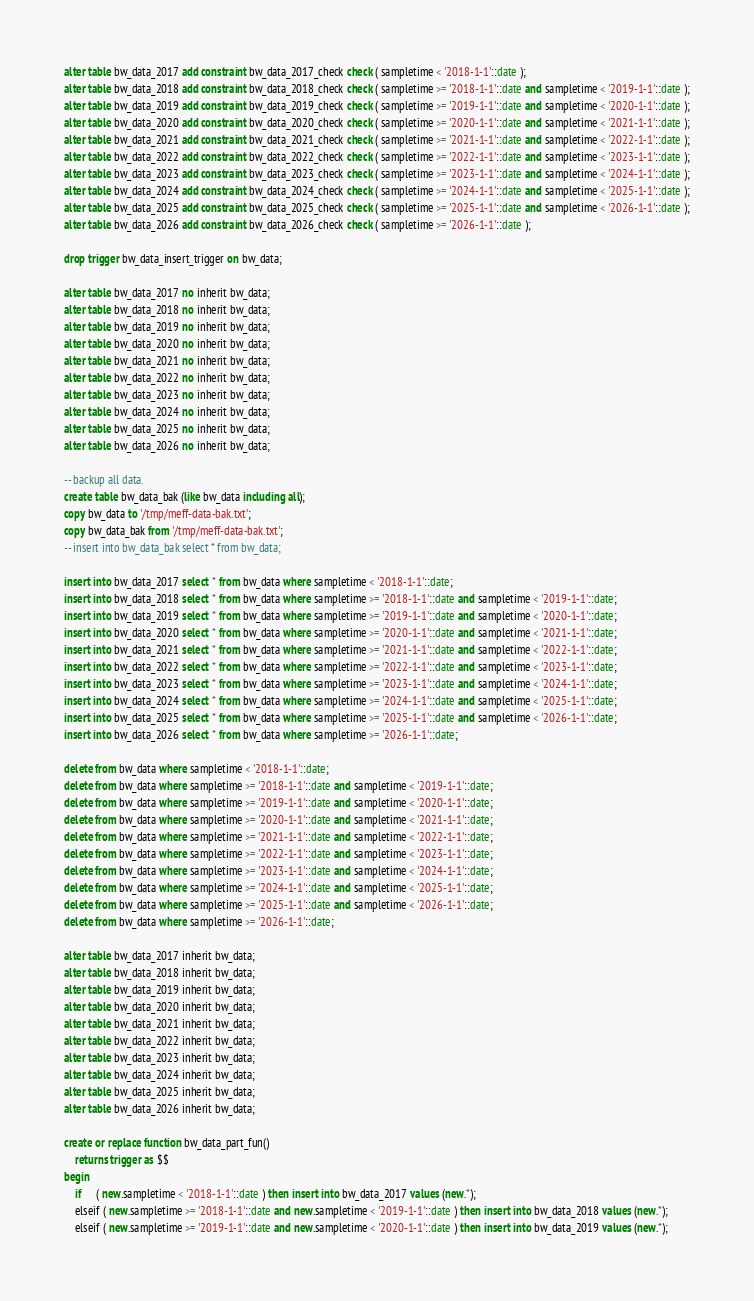Convert code to text. <code><loc_0><loc_0><loc_500><loc_500><_SQL_>
alter table bw_data_2017 add constraint bw_data_2017_check check ( sampletime < '2018-1-1'::date );
alter table bw_data_2018 add constraint bw_data_2018_check check ( sampletime >= '2018-1-1'::date and sampletime < '2019-1-1'::date );
alter table bw_data_2019 add constraint bw_data_2019_check check ( sampletime >= '2019-1-1'::date and sampletime < '2020-1-1'::date );
alter table bw_data_2020 add constraint bw_data_2020_check check ( sampletime >= '2020-1-1'::date and sampletime < '2021-1-1'::date );
alter table bw_data_2021 add constraint bw_data_2021_check check ( sampletime >= '2021-1-1'::date and sampletime < '2022-1-1'::date );
alter table bw_data_2022 add constraint bw_data_2022_check check ( sampletime >= '2022-1-1'::date and sampletime < '2023-1-1'::date );
alter table bw_data_2023 add constraint bw_data_2023_check check ( sampletime >= '2023-1-1'::date and sampletime < '2024-1-1'::date );
alter table bw_data_2024 add constraint bw_data_2024_check check ( sampletime >= '2024-1-1'::date and sampletime < '2025-1-1'::date );
alter table bw_data_2025 add constraint bw_data_2025_check check ( sampletime >= '2025-1-1'::date and sampletime < '2026-1-1'::date );
alter table bw_data_2026 add constraint bw_data_2026_check check ( sampletime >= '2026-1-1'::date );

drop trigger bw_data_insert_trigger on bw_data;

alter table bw_data_2017 no inherit bw_data;
alter table bw_data_2018 no inherit bw_data;
alter table bw_data_2019 no inherit bw_data;
alter table bw_data_2020 no inherit bw_data;
alter table bw_data_2021 no inherit bw_data;
alter table bw_data_2022 no inherit bw_data;
alter table bw_data_2023 no inherit bw_data;
alter table bw_data_2024 no inherit bw_data;
alter table bw_data_2025 no inherit bw_data;
alter table bw_data_2026 no inherit bw_data;

-- backup all data.
create table bw_data_bak (like bw_data including all);
copy bw_data to '/tmp/meff-data-bak.txt';
copy bw_data_bak from '/tmp/meff-data-bak.txt';
-- insert into bw_data_bak select * from bw_data;

insert into bw_data_2017 select * from bw_data where sampletime < '2018-1-1'::date;
insert into bw_data_2018 select * from bw_data where sampletime >= '2018-1-1'::date and sampletime < '2019-1-1'::date;
insert into bw_data_2019 select * from bw_data where sampletime >= '2019-1-1'::date and sampletime < '2020-1-1'::date;
insert into bw_data_2020 select * from bw_data where sampletime >= '2020-1-1'::date and sampletime < '2021-1-1'::date;
insert into bw_data_2021 select * from bw_data where sampletime >= '2021-1-1'::date and sampletime < '2022-1-1'::date;
insert into bw_data_2022 select * from bw_data where sampletime >= '2022-1-1'::date and sampletime < '2023-1-1'::date;
insert into bw_data_2023 select * from bw_data where sampletime >= '2023-1-1'::date and sampletime < '2024-1-1'::date;
insert into bw_data_2024 select * from bw_data where sampletime >= '2024-1-1'::date and sampletime < '2025-1-1'::date;
insert into bw_data_2025 select * from bw_data where sampletime >= '2025-1-1'::date and sampletime < '2026-1-1'::date;
insert into bw_data_2026 select * from bw_data where sampletime >= '2026-1-1'::date;

delete from bw_data where sampletime < '2018-1-1'::date;
delete from bw_data where sampletime >= '2018-1-1'::date and sampletime < '2019-1-1'::date;
delete from bw_data where sampletime >= '2019-1-1'::date and sampletime < '2020-1-1'::date;
delete from bw_data where sampletime >= '2020-1-1'::date and sampletime < '2021-1-1'::date;
delete from bw_data where sampletime >= '2021-1-1'::date and sampletime < '2022-1-1'::date;
delete from bw_data where sampletime >= '2022-1-1'::date and sampletime < '2023-1-1'::date;
delete from bw_data where sampletime >= '2023-1-1'::date and sampletime < '2024-1-1'::date;
delete from bw_data where sampletime >= '2024-1-1'::date and sampletime < '2025-1-1'::date;
delete from bw_data where sampletime >= '2025-1-1'::date and sampletime < '2026-1-1'::date;
delete from bw_data where sampletime >= '2026-1-1'::date;

alter table bw_data_2017 inherit bw_data;
alter table bw_data_2018 inherit bw_data;
alter table bw_data_2019 inherit bw_data;
alter table bw_data_2020 inherit bw_data;
alter table bw_data_2021 inherit bw_data;
alter table bw_data_2022 inherit bw_data;
alter table bw_data_2023 inherit bw_data;
alter table bw_data_2024 inherit bw_data;
alter table bw_data_2025 inherit bw_data;
alter table bw_data_2026 inherit bw_data;

create or replace function bw_data_part_fun()
    returns trigger as $$
begin
    if     ( new.sampletime < '2018-1-1'::date ) then insert into bw_data_2017 values (new.*);
    elseif ( new.sampletime >= '2018-1-1'::date and new.sampletime < '2019-1-1'::date ) then insert into bw_data_2018 values (new.*);
    elseif ( new.sampletime >= '2019-1-1'::date and new.sampletime < '2020-1-1'::date ) then insert into bw_data_2019 values (new.*);</code> 